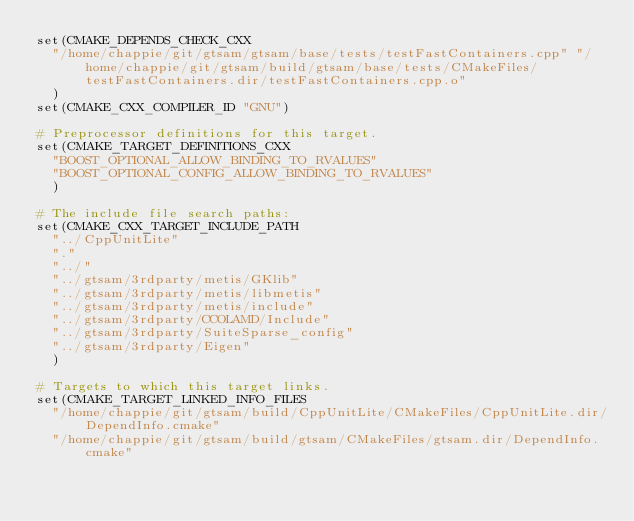Convert code to text. <code><loc_0><loc_0><loc_500><loc_500><_CMake_>set(CMAKE_DEPENDS_CHECK_CXX
  "/home/chappie/git/gtsam/gtsam/base/tests/testFastContainers.cpp" "/home/chappie/git/gtsam/build/gtsam/base/tests/CMakeFiles/testFastContainers.dir/testFastContainers.cpp.o"
  )
set(CMAKE_CXX_COMPILER_ID "GNU")

# Preprocessor definitions for this target.
set(CMAKE_TARGET_DEFINITIONS_CXX
  "BOOST_OPTIONAL_ALLOW_BINDING_TO_RVALUES"
  "BOOST_OPTIONAL_CONFIG_ALLOW_BINDING_TO_RVALUES"
  )

# The include file search paths:
set(CMAKE_CXX_TARGET_INCLUDE_PATH
  "../CppUnitLite"
  "."
  "../"
  "../gtsam/3rdparty/metis/GKlib"
  "../gtsam/3rdparty/metis/libmetis"
  "../gtsam/3rdparty/metis/include"
  "../gtsam/3rdparty/CCOLAMD/Include"
  "../gtsam/3rdparty/SuiteSparse_config"
  "../gtsam/3rdparty/Eigen"
  )

# Targets to which this target links.
set(CMAKE_TARGET_LINKED_INFO_FILES
  "/home/chappie/git/gtsam/build/CppUnitLite/CMakeFiles/CppUnitLite.dir/DependInfo.cmake"
  "/home/chappie/git/gtsam/build/gtsam/CMakeFiles/gtsam.dir/DependInfo.cmake"</code> 